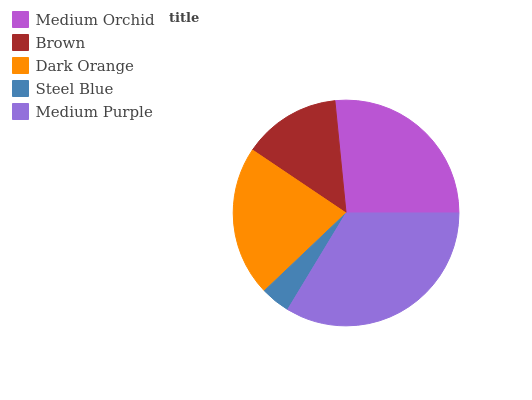Is Steel Blue the minimum?
Answer yes or no. Yes. Is Medium Purple the maximum?
Answer yes or no. Yes. Is Brown the minimum?
Answer yes or no. No. Is Brown the maximum?
Answer yes or no. No. Is Medium Orchid greater than Brown?
Answer yes or no. Yes. Is Brown less than Medium Orchid?
Answer yes or no. Yes. Is Brown greater than Medium Orchid?
Answer yes or no. No. Is Medium Orchid less than Brown?
Answer yes or no. No. Is Dark Orange the high median?
Answer yes or no. Yes. Is Dark Orange the low median?
Answer yes or no. Yes. Is Steel Blue the high median?
Answer yes or no. No. Is Medium Purple the low median?
Answer yes or no. No. 